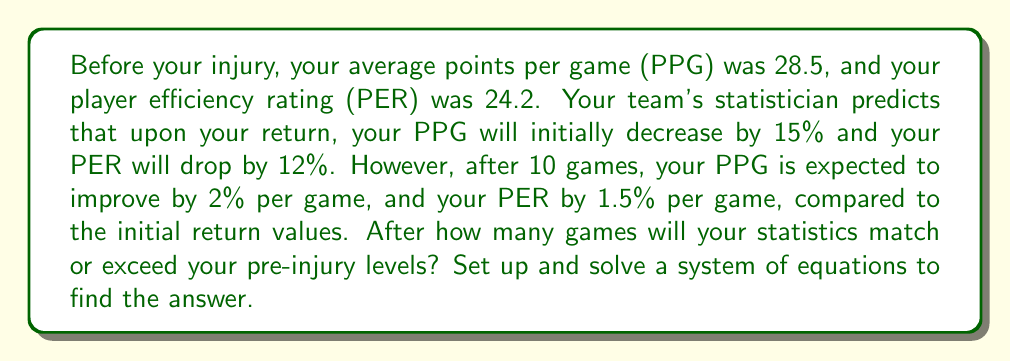Teach me how to tackle this problem. Let's approach this step-by-step:

1) First, let's calculate your initial statistics upon return:
   PPG after return: $28.5 \times (1 - 0.15) = 24.225$
   PER after return: $24.2 \times (1 - 0.12) = 21.296$

2) Now, let's set up variables:
   Let $x$ be the number of games after the initial 10 games.
   
3) We can now set up two equations, one for PPG and one for PER:

   PPG equation: $24.225 \times (1 + 0.02)^{x+10} = 28.5$
   PER equation: $21.296 \times (1 + 0.015)^{x+10} = 24.2$

4) Let's simplify these equations:

   $24.225 \times 1.02^{x+10} = 28.5$
   $21.296 \times 1.015^{x+10} = 24.2$

5) We can solve these using logarithms. Let's start with the PPG equation:

   $\ln(24.225) + (x+10)\ln(1.02) = \ln(28.5)$
   $(x+10)\ln(1.02) = \ln(28.5) - \ln(24.225)$
   $x+10 = \frac{\ln(28.5) - \ln(24.225)}{\ln(1.02)}$
   $x = \frac{\ln(28.5) - \ln(24.225)}{\ln(1.02)} - 10 \approx 5.76$

6) Now for the PER equation:

   $\ln(21.296) + (x+10)\ln(1.015) = \ln(24.2)$
   $(x+10)\ln(1.015) = \ln(24.2) - \ln(21.296)$
   $x+10 = \frac{\ln(24.2) - \ln(21.296)}{\ln(1.015)}$
   $x = \frac{\ln(24.2) - \ln(21.296)}{\ln(1.015)} - 10 \approx 5.95$

7) Since both statistics need to match or exceed pre-injury levels, we take the larger value and round up to the nearest whole number of games.
Answer: 16 games 